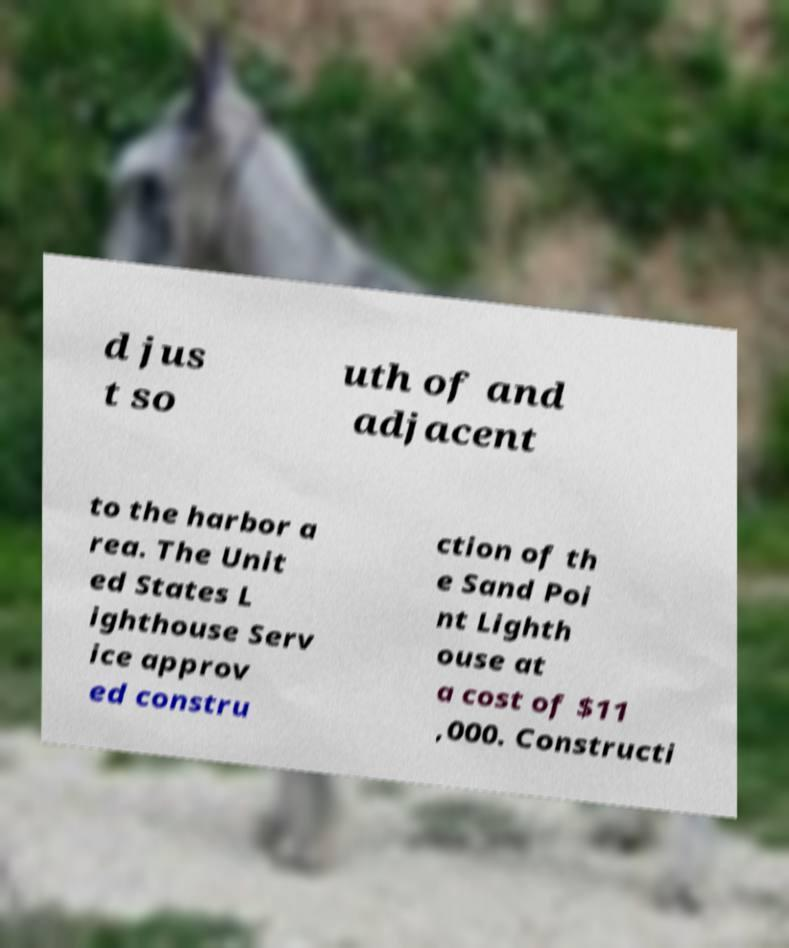What messages or text are displayed in this image? I need them in a readable, typed format. d jus t so uth of and adjacent to the harbor a rea. The Unit ed States L ighthouse Serv ice approv ed constru ction of th e Sand Poi nt Lighth ouse at a cost of $11 ,000. Constructi 